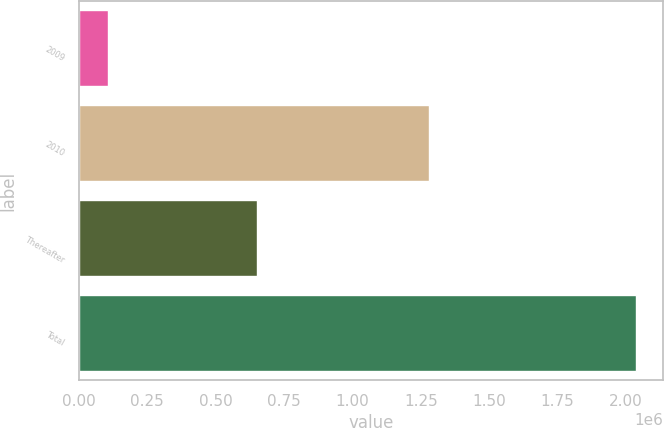<chart> <loc_0><loc_0><loc_500><loc_500><bar_chart><fcel>2009<fcel>2010<fcel>Thereafter<fcel>Total<nl><fcel>105000<fcel>1.28e+06<fcel>650000<fcel>2.035e+06<nl></chart> 